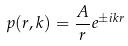Convert formula to latex. <formula><loc_0><loc_0><loc_500><loc_500>p ( r , k ) = \frac { A } { r } e ^ { \pm i k r }</formula> 